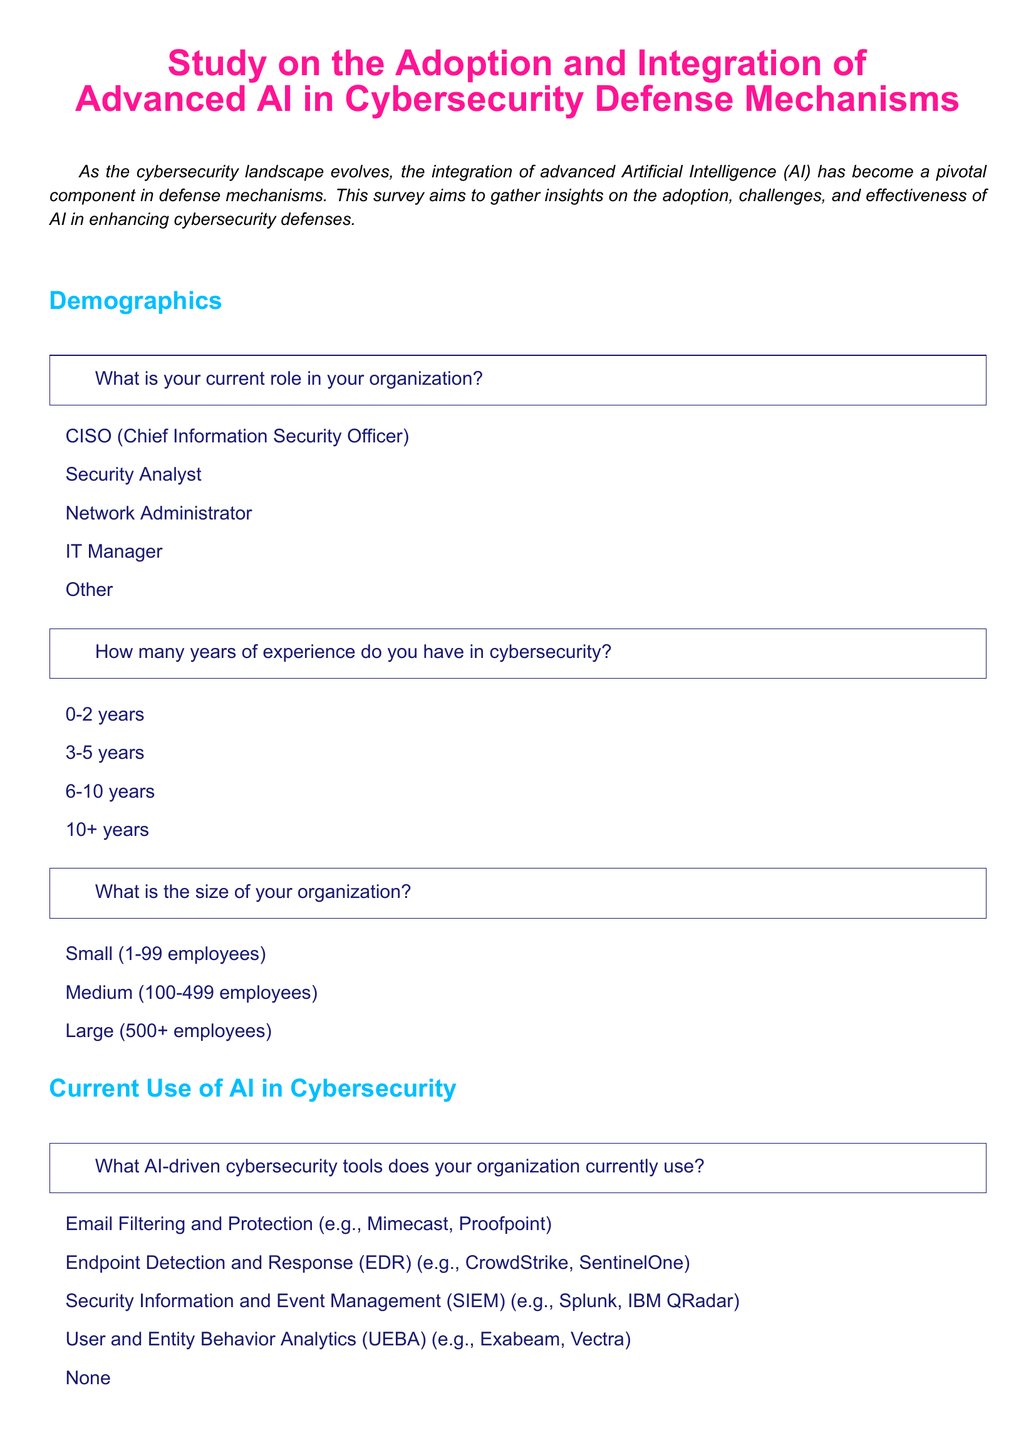What is the title of the study? The title of the study is prominently displayed at the beginning of the document.
Answer: Study on the Adoption and Integration of Advanced AI in Cybersecurity Defense Mechanisms What is the primary purpose of the survey? The purpose of the survey is stated in the introduction, describing its aim to gather insights.
Answer: Gather insights on the adoption, challenges, and effectiveness of AI in enhancing cybersecurity defenses What are the four roles listed under demographics? The document enumerates different roles in the demographics section for participants to choose from.
Answer: CISO, Security Analyst, Network Administrator, IT Manager How many years of experience is categorized as '10+'? This question pertains to the data presented in the experience demographics.
Answer: 10+ years Which AI-driven cybersecurity tool is mentioned first? The first tool listed corresponds to the current AI-driven cybersecurity tools section of the survey.
Answer: Email Filtering and Protection What effectiveness rating corresponds to 'Not Effective'? This inquiry addresses the scale of effectiveness ratings presented in the document.
Answer: 1 What are the main challenges listed for AI adoption in cybersecurity? The document enumerates challenges that organizations face in adopting AI, found in a specific section.
Answer: High Costs, Lack of Skilled Personnel, Integration Issues, Lack of Understanding or Trust, Regulatory and Compliance Issues Which area is expected to benefit the most from AI advancements in cybersecurity? The area highlighted reflects participant beliefs concerning the advantage of future AI advancements.
Answer: Real-time Threat Detection What is the response option indicating 'Very Likely' for future investments? This question seeks to specify the sentiment of investment likelihood in AI-driven solutions.
Answer: Very Likely 